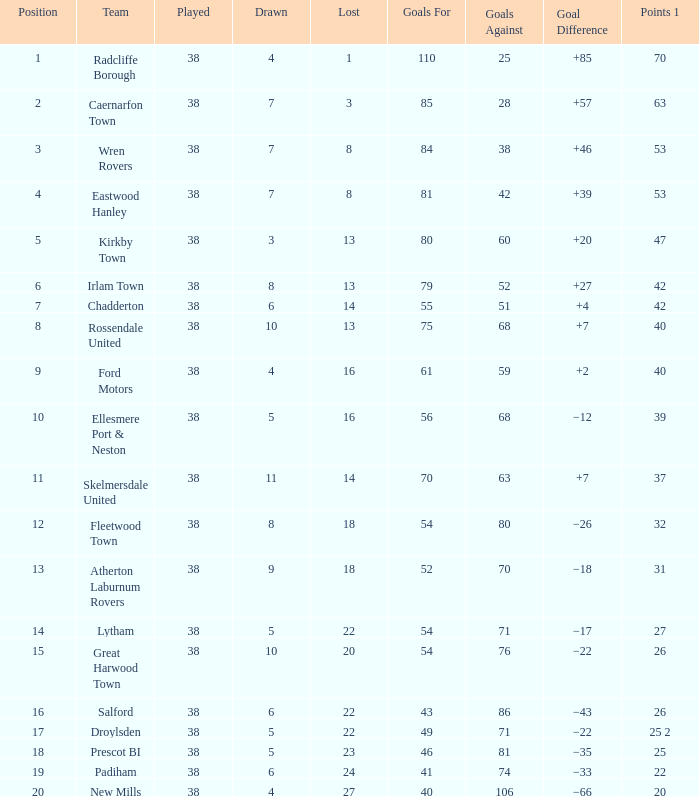How many drawn have goals against exceeding 74, a lost fewer than 20, and a played greater than 38? 0.0. 